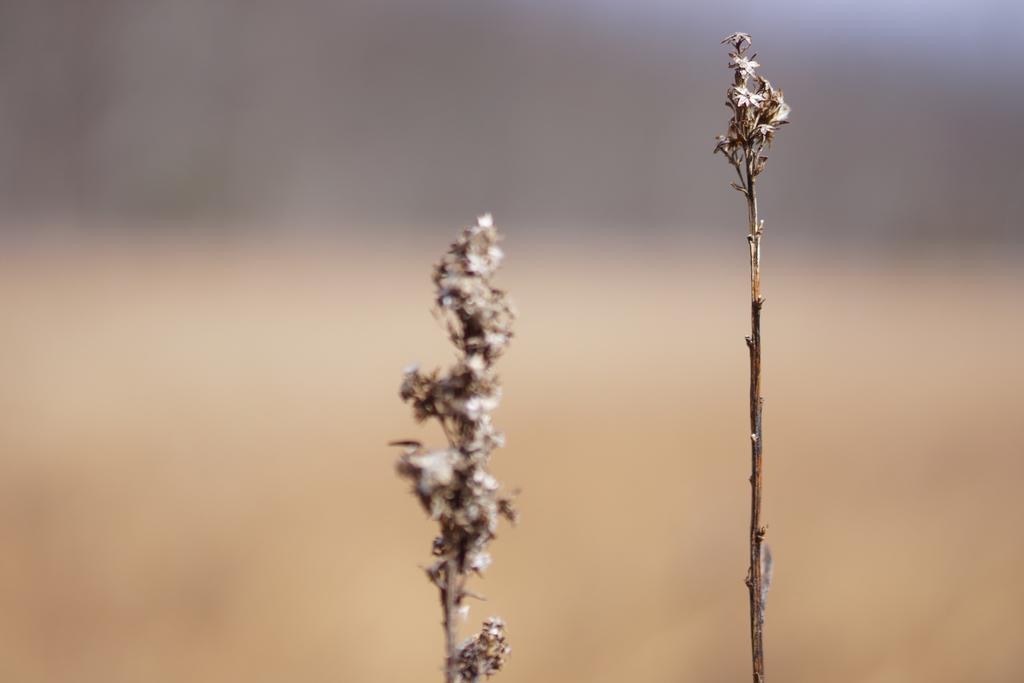What type of plants are present in the image? There are thuja plants in the image. How many books can be seen on the thuja plants in the image? There are no books present on the thuja plants in the image. 